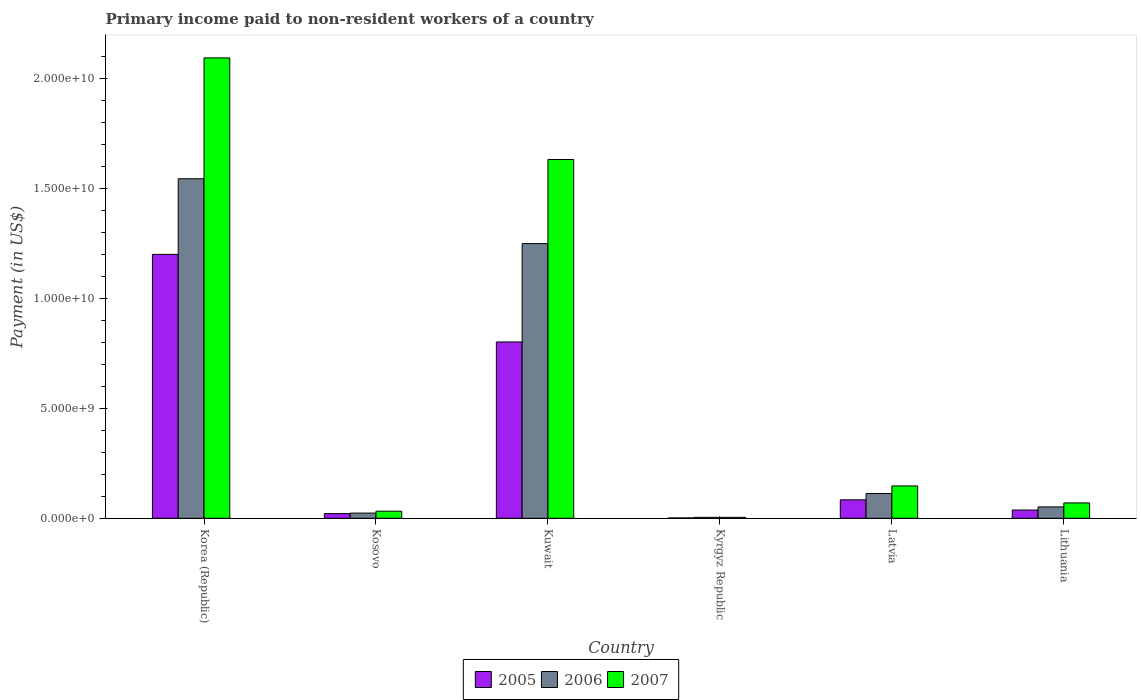How many different coloured bars are there?
Ensure brevity in your answer.  3. Are the number of bars per tick equal to the number of legend labels?
Ensure brevity in your answer.  Yes. Are the number of bars on each tick of the X-axis equal?
Keep it short and to the point. Yes. How many bars are there on the 6th tick from the left?
Your answer should be compact. 3. What is the label of the 6th group of bars from the left?
Your answer should be compact. Lithuania. In how many cases, is the number of bars for a given country not equal to the number of legend labels?
Your response must be concise. 0. What is the amount paid to workers in 2005 in Latvia?
Your answer should be compact. 8.40e+08. Across all countries, what is the maximum amount paid to workers in 2006?
Provide a short and direct response. 1.55e+1. Across all countries, what is the minimum amount paid to workers in 2006?
Your answer should be very brief. 4.16e+07. In which country was the amount paid to workers in 2007 minimum?
Your answer should be very brief. Kyrgyz Republic. What is the total amount paid to workers in 2007 in the graph?
Keep it short and to the point. 3.98e+1. What is the difference between the amount paid to workers in 2006 in Kuwait and that in Latvia?
Offer a terse response. 1.14e+1. What is the difference between the amount paid to workers in 2006 in Korea (Republic) and the amount paid to workers in 2007 in Kuwait?
Give a very brief answer. -8.76e+08. What is the average amount paid to workers in 2005 per country?
Ensure brevity in your answer.  3.58e+09. What is the difference between the amount paid to workers of/in 2007 and amount paid to workers of/in 2005 in Korea (Republic)?
Make the answer very short. 8.94e+09. In how many countries, is the amount paid to workers in 2005 greater than 11000000000 US$?
Provide a succinct answer. 1. What is the ratio of the amount paid to workers in 2007 in Kosovo to that in Lithuania?
Offer a terse response. 0.46. Is the difference between the amount paid to workers in 2007 in Kosovo and Kuwait greater than the difference between the amount paid to workers in 2005 in Kosovo and Kuwait?
Your response must be concise. No. What is the difference between the highest and the second highest amount paid to workers in 2006?
Your answer should be compact. 1.43e+1. What is the difference between the highest and the lowest amount paid to workers in 2005?
Your answer should be very brief. 1.20e+1. In how many countries, is the amount paid to workers in 2006 greater than the average amount paid to workers in 2006 taken over all countries?
Provide a succinct answer. 2. Is the sum of the amount paid to workers in 2006 in Kuwait and Latvia greater than the maximum amount paid to workers in 2007 across all countries?
Your answer should be very brief. No. What does the 3rd bar from the right in Lithuania represents?
Ensure brevity in your answer.  2005. Is it the case that in every country, the sum of the amount paid to workers in 2007 and amount paid to workers in 2005 is greater than the amount paid to workers in 2006?
Your response must be concise. Yes. How many bars are there?
Your answer should be compact. 18. Does the graph contain any zero values?
Ensure brevity in your answer.  No. Does the graph contain grids?
Your answer should be compact. No. Where does the legend appear in the graph?
Offer a terse response. Bottom center. How are the legend labels stacked?
Offer a terse response. Horizontal. What is the title of the graph?
Give a very brief answer. Primary income paid to non-resident workers of a country. Does "1962" appear as one of the legend labels in the graph?
Your answer should be very brief. No. What is the label or title of the X-axis?
Offer a terse response. Country. What is the label or title of the Y-axis?
Make the answer very short. Payment (in US$). What is the Payment (in US$) of 2005 in Korea (Republic)?
Provide a succinct answer. 1.20e+1. What is the Payment (in US$) of 2006 in Korea (Republic)?
Give a very brief answer. 1.55e+1. What is the Payment (in US$) in 2007 in Korea (Republic)?
Make the answer very short. 2.09e+1. What is the Payment (in US$) of 2005 in Kosovo?
Provide a succinct answer. 2.12e+08. What is the Payment (in US$) of 2006 in Kosovo?
Provide a short and direct response. 2.36e+08. What is the Payment (in US$) of 2007 in Kosovo?
Provide a short and direct response. 3.23e+08. What is the Payment (in US$) of 2005 in Kuwait?
Keep it short and to the point. 8.02e+09. What is the Payment (in US$) of 2006 in Kuwait?
Your answer should be compact. 1.25e+1. What is the Payment (in US$) in 2007 in Kuwait?
Your answer should be very brief. 1.63e+1. What is the Payment (in US$) in 2005 in Kyrgyz Republic?
Provide a short and direct response. 1.65e+07. What is the Payment (in US$) in 2006 in Kyrgyz Republic?
Keep it short and to the point. 4.16e+07. What is the Payment (in US$) in 2007 in Kyrgyz Republic?
Offer a terse response. 4.26e+07. What is the Payment (in US$) in 2005 in Latvia?
Your response must be concise. 8.40e+08. What is the Payment (in US$) in 2006 in Latvia?
Provide a succinct answer. 1.13e+09. What is the Payment (in US$) of 2007 in Latvia?
Make the answer very short. 1.47e+09. What is the Payment (in US$) of 2005 in Lithuania?
Your answer should be very brief. 3.75e+08. What is the Payment (in US$) of 2006 in Lithuania?
Make the answer very short. 5.17e+08. What is the Payment (in US$) of 2007 in Lithuania?
Offer a terse response. 6.99e+08. Across all countries, what is the maximum Payment (in US$) in 2005?
Give a very brief answer. 1.20e+1. Across all countries, what is the maximum Payment (in US$) in 2006?
Give a very brief answer. 1.55e+1. Across all countries, what is the maximum Payment (in US$) in 2007?
Offer a terse response. 2.09e+1. Across all countries, what is the minimum Payment (in US$) in 2005?
Your response must be concise. 1.65e+07. Across all countries, what is the minimum Payment (in US$) in 2006?
Keep it short and to the point. 4.16e+07. Across all countries, what is the minimum Payment (in US$) of 2007?
Offer a terse response. 4.26e+07. What is the total Payment (in US$) in 2005 in the graph?
Give a very brief answer. 2.15e+1. What is the total Payment (in US$) in 2006 in the graph?
Give a very brief answer. 2.99e+1. What is the total Payment (in US$) of 2007 in the graph?
Offer a terse response. 3.98e+1. What is the difference between the Payment (in US$) of 2005 in Korea (Republic) and that in Kosovo?
Your response must be concise. 1.18e+1. What is the difference between the Payment (in US$) of 2006 in Korea (Republic) and that in Kosovo?
Offer a terse response. 1.52e+1. What is the difference between the Payment (in US$) of 2007 in Korea (Republic) and that in Kosovo?
Keep it short and to the point. 2.06e+1. What is the difference between the Payment (in US$) of 2005 in Korea (Republic) and that in Kuwait?
Make the answer very short. 3.99e+09. What is the difference between the Payment (in US$) in 2006 in Korea (Republic) and that in Kuwait?
Your answer should be compact. 2.95e+09. What is the difference between the Payment (in US$) in 2007 in Korea (Republic) and that in Kuwait?
Your response must be concise. 4.62e+09. What is the difference between the Payment (in US$) of 2005 in Korea (Republic) and that in Kyrgyz Republic?
Offer a terse response. 1.20e+1. What is the difference between the Payment (in US$) of 2006 in Korea (Republic) and that in Kyrgyz Republic?
Your answer should be compact. 1.54e+1. What is the difference between the Payment (in US$) in 2007 in Korea (Republic) and that in Kyrgyz Republic?
Keep it short and to the point. 2.09e+1. What is the difference between the Payment (in US$) in 2005 in Korea (Republic) and that in Latvia?
Offer a very short reply. 1.12e+1. What is the difference between the Payment (in US$) of 2006 in Korea (Republic) and that in Latvia?
Give a very brief answer. 1.43e+1. What is the difference between the Payment (in US$) of 2007 in Korea (Republic) and that in Latvia?
Give a very brief answer. 1.95e+1. What is the difference between the Payment (in US$) of 2005 in Korea (Republic) and that in Lithuania?
Your answer should be compact. 1.16e+1. What is the difference between the Payment (in US$) in 2006 in Korea (Republic) and that in Lithuania?
Provide a short and direct response. 1.49e+1. What is the difference between the Payment (in US$) of 2007 in Korea (Republic) and that in Lithuania?
Your answer should be compact. 2.03e+1. What is the difference between the Payment (in US$) in 2005 in Kosovo and that in Kuwait?
Keep it short and to the point. -7.81e+09. What is the difference between the Payment (in US$) of 2006 in Kosovo and that in Kuwait?
Give a very brief answer. -1.23e+1. What is the difference between the Payment (in US$) of 2007 in Kosovo and that in Kuwait?
Offer a very short reply. -1.60e+1. What is the difference between the Payment (in US$) in 2005 in Kosovo and that in Kyrgyz Republic?
Keep it short and to the point. 1.95e+08. What is the difference between the Payment (in US$) of 2006 in Kosovo and that in Kyrgyz Republic?
Keep it short and to the point. 1.94e+08. What is the difference between the Payment (in US$) of 2007 in Kosovo and that in Kyrgyz Republic?
Your answer should be compact. 2.80e+08. What is the difference between the Payment (in US$) of 2005 in Kosovo and that in Latvia?
Provide a short and direct response. -6.28e+08. What is the difference between the Payment (in US$) of 2006 in Kosovo and that in Latvia?
Keep it short and to the point. -8.91e+08. What is the difference between the Payment (in US$) of 2007 in Kosovo and that in Latvia?
Your answer should be very brief. -1.15e+09. What is the difference between the Payment (in US$) in 2005 in Kosovo and that in Lithuania?
Offer a very short reply. -1.63e+08. What is the difference between the Payment (in US$) of 2006 in Kosovo and that in Lithuania?
Provide a short and direct response. -2.82e+08. What is the difference between the Payment (in US$) in 2007 in Kosovo and that in Lithuania?
Make the answer very short. -3.76e+08. What is the difference between the Payment (in US$) in 2005 in Kuwait and that in Kyrgyz Republic?
Your answer should be compact. 8.01e+09. What is the difference between the Payment (in US$) in 2006 in Kuwait and that in Kyrgyz Republic?
Keep it short and to the point. 1.25e+1. What is the difference between the Payment (in US$) of 2007 in Kuwait and that in Kyrgyz Republic?
Your answer should be compact. 1.63e+1. What is the difference between the Payment (in US$) in 2005 in Kuwait and that in Latvia?
Your response must be concise. 7.18e+09. What is the difference between the Payment (in US$) of 2006 in Kuwait and that in Latvia?
Give a very brief answer. 1.14e+1. What is the difference between the Payment (in US$) of 2007 in Kuwait and that in Latvia?
Provide a short and direct response. 1.49e+1. What is the difference between the Payment (in US$) of 2005 in Kuwait and that in Lithuania?
Your response must be concise. 7.65e+09. What is the difference between the Payment (in US$) in 2006 in Kuwait and that in Lithuania?
Offer a very short reply. 1.20e+1. What is the difference between the Payment (in US$) of 2007 in Kuwait and that in Lithuania?
Keep it short and to the point. 1.56e+1. What is the difference between the Payment (in US$) of 2005 in Kyrgyz Republic and that in Latvia?
Your response must be concise. -8.23e+08. What is the difference between the Payment (in US$) in 2006 in Kyrgyz Republic and that in Latvia?
Provide a succinct answer. -1.09e+09. What is the difference between the Payment (in US$) in 2007 in Kyrgyz Republic and that in Latvia?
Make the answer very short. -1.43e+09. What is the difference between the Payment (in US$) in 2005 in Kyrgyz Republic and that in Lithuania?
Ensure brevity in your answer.  -3.58e+08. What is the difference between the Payment (in US$) of 2006 in Kyrgyz Republic and that in Lithuania?
Give a very brief answer. -4.76e+08. What is the difference between the Payment (in US$) of 2007 in Kyrgyz Republic and that in Lithuania?
Your answer should be very brief. -6.56e+08. What is the difference between the Payment (in US$) of 2005 in Latvia and that in Lithuania?
Offer a terse response. 4.65e+08. What is the difference between the Payment (in US$) of 2006 in Latvia and that in Lithuania?
Provide a succinct answer. 6.10e+08. What is the difference between the Payment (in US$) in 2007 in Latvia and that in Lithuania?
Make the answer very short. 7.72e+08. What is the difference between the Payment (in US$) in 2005 in Korea (Republic) and the Payment (in US$) in 2006 in Kosovo?
Ensure brevity in your answer.  1.18e+1. What is the difference between the Payment (in US$) of 2005 in Korea (Republic) and the Payment (in US$) of 2007 in Kosovo?
Your answer should be compact. 1.17e+1. What is the difference between the Payment (in US$) of 2006 in Korea (Republic) and the Payment (in US$) of 2007 in Kosovo?
Your response must be concise. 1.51e+1. What is the difference between the Payment (in US$) in 2005 in Korea (Republic) and the Payment (in US$) in 2006 in Kuwait?
Your answer should be very brief. -4.92e+08. What is the difference between the Payment (in US$) of 2005 in Korea (Republic) and the Payment (in US$) of 2007 in Kuwait?
Your answer should be very brief. -4.32e+09. What is the difference between the Payment (in US$) in 2006 in Korea (Republic) and the Payment (in US$) in 2007 in Kuwait?
Provide a succinct answer. -8.76e+08. What is the difference between the Payment (in US$) of 2005 in Korea (Republic) and the Payment (in US$) of 2006 in Kyrgyz Republic?
Provide a succinct answer. 1.20e+1. What is the difference between the Payment (in US$) of 2005 in Korea (Republic) and the Payment (in US$) of 2007 in Kyrgyz Republic?
Offer a very short reply. 1.20e+1. What is the difference between the Payment (in US$) of 2006 in Korea (Republic) and the Payment (in US$) of 2007 in Kyrgyz Republic?
Provide a succinct answer. 1.54e+1. What is the difference between the Payment (in US$) of 2005 in Korea (Republic) and the Payment (in US$) of 2006 in Latvia?
Provide a succinct answer. 1.09e+1. What is the difference between the Payment (in US$) of 2005 in Korea (Republic) and the Payment (in US$) of 2007 in Latvia?
Provide a succinct answer. 1.05e+1. What is the difference between the Payment (in US$) in 2006 in Korea (Republic) and the Payment (in US$) in 2007 in Latvia?
Offer a terse response. 1.40e+1. What is the difference between the Payment (in US$) of 2005 in Korea (Republic) and the Payment (in US$) of 2006 in Lithuania?
Your answer should be very brief. 1.15e+1. What is the difference between the Payment (in US$) in 2005 in Korea (Republic) and the Payment (in US$) in 2007 in Lithuania?
Offer a terse response. 1.13e+1. What is the difference between the Payment (in US$) of 2006 in Korea (Republic) and the Payment (in US$) of 2007 in Lithuania?
Keep it short and to the point. 1.48e+1. What is the difference between the Payment (in US$) in 2005 in Kosovo and the Payment (in US$) in 2006 in Kuwait?
Keep it short and to the point. -1.23e+1. What is the difference between the Payment (in US$) in 2005 in Kosovo and the Payment (in US$) in 2007 in Kuwait?
Your answer should be compact. -1.61e+1. What is the difference between the Payment (in US$) in 2006 in Kosovo and the Payment (in US$) in 2007 in Kuwait?
Your answer should be compact. -1.61e+1. What is the difference between the Payment (in US$) of 2005 in Kosovo and the Payment (in US$) of 2006 in Kyrgyz Republic?
Your response must be concise. 1.70e+08. What is the difference between the Payment (in US$) of 2005 in Kosovo and the Payment (in US$) of 2007 in Kyrgyz Republic?
Your answer should be very brief. 1.69e+08. What is the difference between the Payment (in US$) of 2006 in Kosovo and the Payment (in US$) of 2007 in Kyrgyz Republic?
Your response must be concise. 1.93e+08. What is the difference between the Payment (in US$) in 2005 in Kosovo and the Payment (in US$) in 2006 in Latvia?
Provide a short and direct response. -9.15e+08. What is the difference between the Payment (in US$) of 2005 in Kosovo and the Payment (in US$) of 2007 in Latvia?
Provide a succinct answer. -1.26e+09. What is the difference between the Payment (in US$) in 2006 in Kosovo and the Payment (in US$) in 2007 in Latvia?
Give a very brief answer. -1.24e+09. What is the difference between the Payment (in US$) in 2005 in Kosovo and the Payment (in US$) in 2006 in Lithuania?
Give a very brief answer. -3.05e+08. What is the difference between the Payment (in US$) in 2005 in Kosovo and the Payment (in US$) in 2007 in Lithuania?
Give a very brief answer. -4.87e+08. What is the difference between the Payment (in US$) in 2006 in Kosovo and the Payment (in US$) in 2007 in Lithuania?
Your answer should be very brief. -4.63e+08. What is the difference between the Payment (in US$) of 2005 in Kuwait and the Payment (in US$) of 2006 in Kyrgyz Republic?
Give a very brief answer. 7.98e+09. What is the difference between the Payment (in US$) in 2005 in Kuwait and the Payment (in US$) in 2007 in Kyrgyz Republic?
Offer a very short reply. 7.98e+09. What is the difference between the Payment (in US$) in 2006 in Kuwait and the Payment (in US$) in 2007 in Kyrgyz Republic?
Offer a very short reply. 1.25e+1. What is the difference between the Payment (in US$) of 2005 in Kuwait and the Payment (in US$) of 2006 in Latvia?
Offer a terse response. 6.90e+09. What is the difference between the Payment (in US$) of 2005 in Kuwait and the Payment (in US$) of 2007 in Latvia?
Your answer should be compact. 6.55e+09. What is the difference between the Payment (in US$) of 2006 in Kuwait and the Payment (in US$) of 2007 in Latvia?
Give a very brief answer. 1.10e+1. What is the difference between the Payment (in US$) of 2005 in Kuwait and the Payment (in US$) of 2006 in Lithuania?
Your response must be concise. 7.51e+09. What is the difference between the Payment (in US$) of 2005 in Kuwait and the Payment (in US$) of 2007 in Lithuania?
Provide a succinct answer. 7.32e+09. What is the difference between the Payment (in US$) in 2006 in Kuwait and the Payment (in US$) in 2007 in Lithuania?
Ensure brevity in your answer.  1.18e+1. What is the difference between the Payment (in US$) of 2005 in Kyrgyz Republic and the Payment (in US$) of 2006 in Latvia?
Your response must be concise. -1.11e+09. What is the difference between the Payment (in US$) of 2005 in Kyrgyz Republic and the Payment (in US$) of 2007 in Latvia?
Make the answer very short. -1.45e+09. What is the difference between the Payment (in US$) in 2006 in Kyrgyz Republic and the Payment (in US$) in 2007 in Latvia?
Your answer should be compact. -1.43e+09. What is the difference between the Payment (in US$) of 2005 in Kyrgyz Republic and the Payment (in US$) of 2006 in Lithuania?
Your answer should be very brief. -5.01e+08. What is the difference between the Payment (in US$) in 2005 in Kyrgyz Republic and the Payment (in US$) in 2007 in Lithuania?
Make the answer very short. -6.82e+08. What is the difference between the Payment (in US$) in 2006 in Kyrgyz Republic and the Payment (in US$) in 2007 in Lithuania?
Keep it short and to the point. -6.57e+08. What is the difference between the Payment (in US$) in 2005 in Latvia and the Payment (in US$) in 2006 in Lithuania?
Keep it short and to the point. 3.22e+08. What is the difference between the Payment (in US$) in 2005 in Latvia and the Payment (in US$) in 2007 in Lithuania?
Your answer should be compact. 1.41e+08. What is the difference between the Payment (in US$) of 2006 in Latvia and the Payment (in US$) of 2007 in Lithuania?
Offer a terse response. 4.28e+08. What is the average Payment (in US$) in 2005 per country?
Keep it short and to the point. 3.58e+09. What is the average Payment (in US$) of 2006 per country?
Offer a terse response. 4.98e+09. What is the average Payment (in US$) in 2007 per country?
Provide a succinct answer. 6.64e+09. What is the difference between the Payment (in US$) of 2005 and Payment (in US$) of 2006 in Korea (Republic)?
Provide a succinct answer. -3.44e+09. What is the difference between the Payment (in US$) in 2005 and Payment (in US$) in 2007 in Korea (Republic)?
Your answer should be compact. -8.94e+09. What is the difference between the Payment (in US$) in 2006 and Payment (in US$) in 2007 in Korea (Republic)?
Ensure brevity in your answer.  -5.50e+09. What is the difference between the Payment (in US$) of 2005 and Payment (in US$) of 2006 in Kosovo?
Make the answer very short. -2.36e+07. What is the difference between the Payment (in US$) in 2005 and Payment (in US$) in 2007 in Kosovo?
Provide a short and direct response. -1.11e+08. What is the difference between the Payment (in US$) in 2006 and Payment (in US$) in 2007 in Kosovo?
Offer a terse response. -8.69e+07. What is the difference between the Payment (in US$) in 2005 and Payment (in US$) in 2006 in Kuwait?
Give a very brief answer. -4.48e+09. What is the difference between the Payment (in US$) in 2005 and Payment (in US$) in 2007 in Kuwait?
Keep it short and to the point. -8.30e+09. What is the difference between the Payment (in US$) in 2006 and Payment (in US$) in 2007 in Kuwait?
Provide a succinct answer. -3.83e+09. What is the difference between the Payment (in US$) of 2005 and Payment (in US$) of 2006 in Kyrgyz Republic?
Offer a very short reply. -2.51e+07. What is the difference between the Payment (in US$) of 2005 and Payment (in US$) of 2007 in Kyrgyz Republic?
Provide a succinct answer. -2.61e+07. What is the difference between the Payment (in US$) in 2006 and Payment (in US$) in 2007 in Kyrgyz Republic?
Ensure brevity in your answer.  -1.00e+06. What is the difference between the Payment (in US$) in 2005 and Payment (in US$) in 2006 in Latvia?
Offer a very short reply. -2.87e+08. What is the difference between the Payment (in US$) in 2005 and Payment (in US$) in 2007 in Latvia?
Offer a very short reply. -6.31e+08. What is the difference between the Payment (in US$) in 2006 and Payment (in US$) in 2007 in Latvia?
Your answer should be very brief. -3.44e+08. What is the difference between the Payment (in US$) in 2005 and Payment (in US$) in 2006 in Lithuania?
Your answer should be very brief. -1.42e+08. What is the difference between the Payment (in US$) of 2005 and Payment (in US$) of 2007 in Lithuania?
Provide a short and direct response. -3.24e+08. What is the difference between the Payment (in US$) of 2006 and Payment (in US$) of 2007 in Lithuania?
Keep it short and to the point. -1.82e+08. What is the ratio of the Payment (in US$) of 2005 in Korea (Republic) to that in Kosovo?
Provide a succinct answer. 56.64. What is the ratio of the Payment (in US$) of 2006 in Korea (Republic) to that in Kosovo?
Provide a short and direct response. 65.58. What is the ratio of the Payment (in US$) of 2007 in Korea (Republic) to that in Kosovo?
Offer a terse response. 64.95. What is the ratio of the Payment (in US$) of 2005 in Korea (Republic) to that in Kuwait?
Provide a succinct answer. 1.5. What is the ratio of the Payment (in US$) of 2006 in Korea (Republic) to that in Kuwait?
Your answer should be very brief. 1.24. What is the ratio of the Payment (in US$) in 2007 in Korea (Republic) to that in Kuwait?
Ensure brevity in your answer.  1.28. What is the ratio of the Payment (in US$) in 2005 in Korea (Republic) to that in Kyrgyz Republic?
Your response must be concise. 726.25. What is the ratio of the Payment (in US$) of 2006 in Korea (Republic) to that in Kyrgyz Republic?
Offer a terse response. 371.2. What is the ratio of the Payment (in US$) in 2007 in Korea (Republic) to that in Kyrgyz Republic?
Offer a terse response. 491.48. What is the ratio of the Payment (in US$) of 2005 in Korea (Republic) to that in Latvia?
Give a very brief answer. 14.3. What is the ratio of the Payment (in US$) in 2006 in Korea (Republic) to that in Latvia?
Give a very brief answer. 13.71. What is the ratio of the Payment (in US$) in 2007 in Korea (Republic) to that in Latvia?
Provide a short and direct response. 14.24. What is the ratio of the Payment (in US$) in 2005 in Korea (Republic) to that in Lithuania?
Your response must be concise. 32.03. What is the ratio of the Payment (in US$) in 2006 in Korea (Republic) to that in Lithuania?
Your answer should be very brief. 29.87. What is the ratio of the Payment (in US$) of 2007 in Korea (Republic) to that in Lithuania?
Your answer should be very brief. 29.97. What is the ratio of the Payment (in US$) in 2005 in Kosovo to that in Kuwait?
Your response must be concise. 0.03. What is the ratio of the Payment (in US$) of 2006 in Kosovo to that in Kuwait?
Keep it short and to the point. 0.02. What is the ratio of the Payment (in US$) of 2007 in Kosovo to that in Kuwait?
Make the answer very short. 0.02. What is the ratio of the Payment (in US$) in 2005 in Kosovo to that in Kyrgyz Republic?
Offer a very short reply. 12.82. What is the ratio of the Payment (in US$) of 2006 in Kosovo to that in Kyrgyz Republic?
Offer a terse response. 5.66. What is the ratio of the Payment (in US$) of 2007 in Kosovo to that in Kyrgyz Republic?
Provide a succinct answer. 7.57. What is the ratio of the Payment (in US$) of 2005 in Kosovo to that in Latvia?
Keep it short and to the point. 0.25. What is the ratio of the Payment (in US$) in 2006 in Kosovo to that in Latvia?
Offer a very short reply. 0.21. What is the ratio of the Payment (in US$) of 2007 in Kosovo to that in Latvia?
Provide a short and direct response. 0.22. What is the ratio of the Payment (in US$) in 2005 in Kosovo to that in Lithuania?
Make the answer very short. 0.57. What is the ratio of the Payment (in US$) of 2006 in Kosovo to that in Lithuania?
Make the answer very short. 0.46. What is the ratio of the Payment (in US$) in 2007 in Kosovo to that in Lithuania?
Offer a terse response. 0.46. What is the ratio of the Payment (in US$) of 2005 in Kuwait to that in Kyrgyz Republic?
Offer a terse response. 485.22. What is the ratio of the Payment (in US$) of 2006 in Kuwait to that in Kyrgyz Republic?
Keep it short and to the point. 300.29. What is the ratio of the Payment (in US$) of 2007 in Kuwait to that in Kyrgyz Republic?
Your answer should be compact. 383.03. What is the ratio of the Payment (in US$) of 2005 in Kuwait to that in Latvia?
Make the answer very short. 9.55. What is the ratio of the Payment (in US$) of 2006 in Kuwait to that in Latvia?
Your response must be concise. 11.09. What is the ratio of the Payment (in US$) in 2007 in Kuwait to that in Latvia?
Offer a very short reply. 11.1. What is the ratio of the Payment (in US$) of 2005 in Kuwait to that in Lithuania?
Offer a very short reply. 21.4. What is the ratio of the Payment (in US$) in 2006 in Kuwait to that in Lithuania?
Give a very brief answer. 24.16. What is the ratio of the Payment (in US$) in 2007 in Kuwait to that in Lithuania?
Keep it short and to the point. 23.36. What is the ratio of the Payment (in US$) of 2005 in Kyrgyz Republic to that in Latvia?
Your answer should be very brief. 0.02. What is the ratio of the Payment (in US$) in 2006 in Kyrgyz Republic to that in Latvia?
Offer a terse response. 0.04. What is the ratio of the Payment (in US$) of 2007 in Kyrgyz Republic to that in Latvia?
Make the answer very short. 0.03. What is the ratio of the Payment (in US$) of 2005 in Kyrgyz Republic to that in Lithuania?
Provide a succinct answer. 0.04. What is the ratio of the Payment (in US$) in 2006 in Kyrgyz Republic to that in Lithuania?
Your answer should be compact. 0.08. What is the ratio of the Payment (in US$) of 2007 in Kyrgyz Republic to that in Lithuania?
Provide a succinct answer. 0.06. What is the ratio of the Payment (in US$) in 2005 in Latvia to that in Lithuania?
Ensure brevity in your answer.  2.24. What is the ratio of the Payment (in US$) of 2006 in Latvia to that in Lithuania?
Keep it short and to the point. 2.18. What is the ratio of the Payment (in US$) in 2007 in Latvia to that in Lithuania?
Make the answer very short. 2.1. What is the difference between the highest and the second highest Payment (in US$) in 2005?
Keep it short and to the point. 3.99e+09. What is the difference between the highest and the second highest Payment (in US$) of 2006?
Make the answer very short. 2.95e+09. What is the difference between the highest and the second highest Payment (in US$) of 2007?
Keep it short and to the point. 4.62e+09. What is the difference between the highest and the lowest Payment (in US$) in 2005?
Make the answer very short. 1.20e+1. What is the difference between the highest and the lowest Payment (in US$) of 2006?
Provide a short and direct response. 1.54e+1. What is the difference between the highest and the lowest Payment (in US$) of 2007?
Offer a terse response. 2.09e+1. 